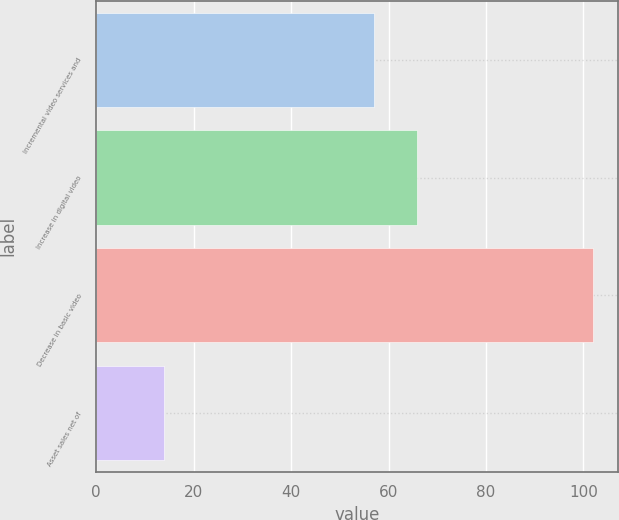Convert chart. <chart><loc_0><loc_0><loc_500><loc_500><bar_chart><fcel>Incremental video services and<fcel>Increase in digital video<fcel>Decrease in basic video<fcel>Asset sales net of<nl><fcel>57<fcel>65.8<fcel>102<fcel>14<nl></chart> 